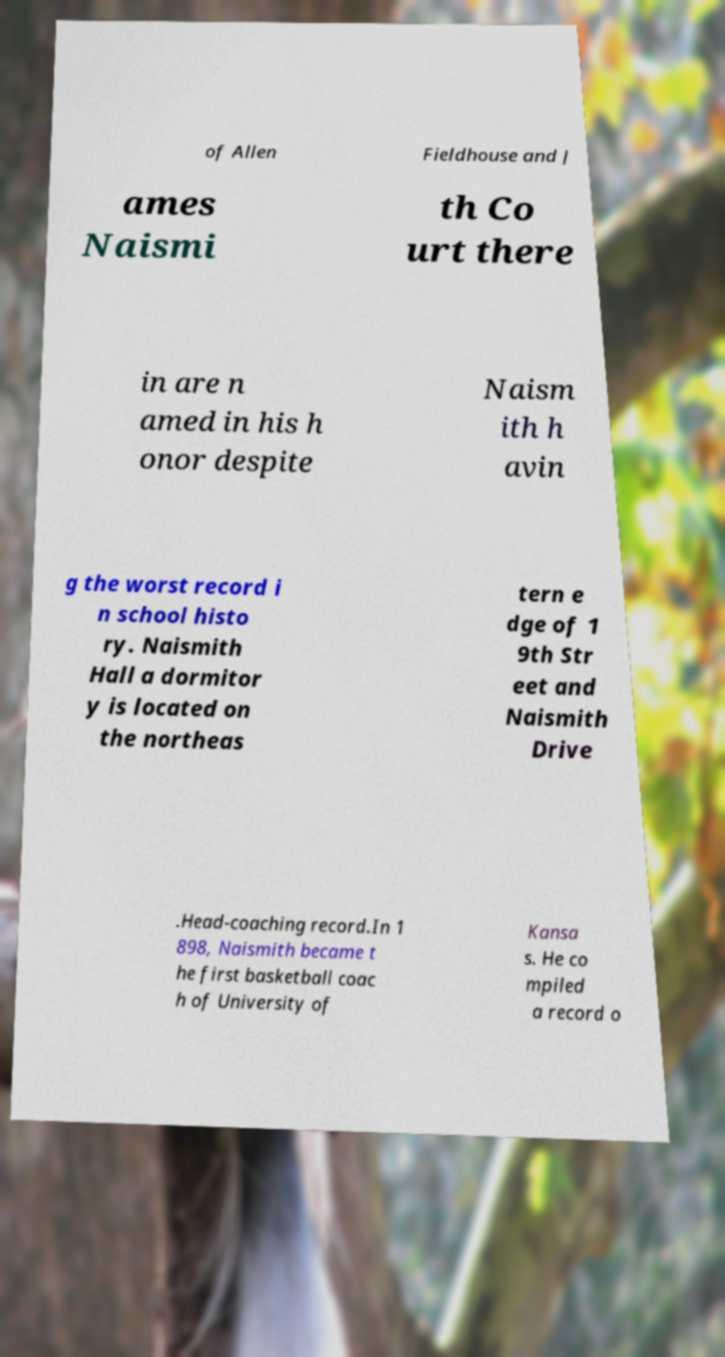Can you read and provide the text displayed in the image?This photo seems to have some interesting text. Can you extract and type it out for me? of Allen Fieldhouse and J ames Naismi th Co urt there in are n amed in his h onor despite Naism ith h avin g the worst record i n school histo ry. Naismith Hall a dormitor y is located on the northeas tern e dge of 1 9th Str eet and Naismith Drive .Head-coaching record.In 1 898, Naismith became t he first basketball coac h of University of Kansa s. He co mpiled a record o 